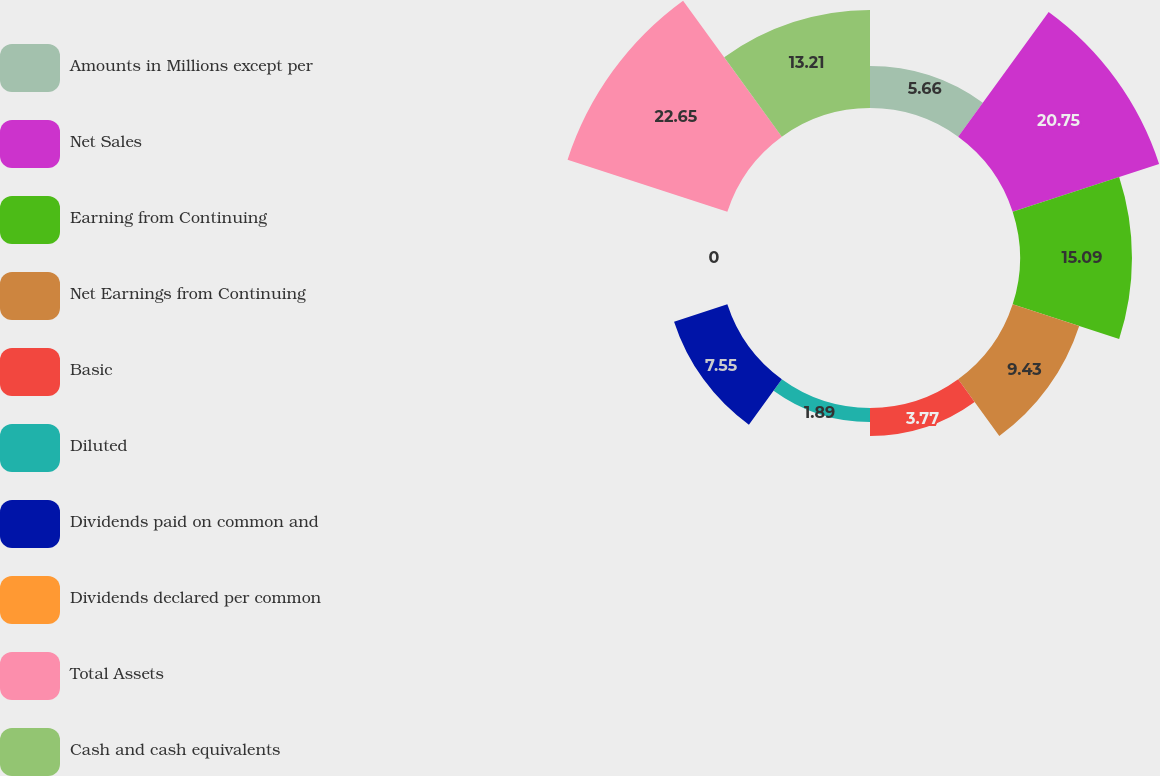Convert chart. <chart><loc_0><loc_0><loc_500><loc_500><pie_chart><fcel>Amounts in Millions except per<fcel>Net Sales<fcel>Earning from Continuing<fcel>Net Earnings from Continuing<fcel>Basic<fcel>Diluted<fcel>Dividends paid on common and<fcel>Dividends declared per common<fcel>Total Assets<fcel>Cash and cash equivalents<nl><fcel>5.66%<fcel>20.75%<fcel>15.09%<fcel>9.43%<fcel>3.77%<fcel>1.89%<fcel>7.55%<fcel>0.0%<fcel>22.64%<fcel>13.21%<nl></chart> 